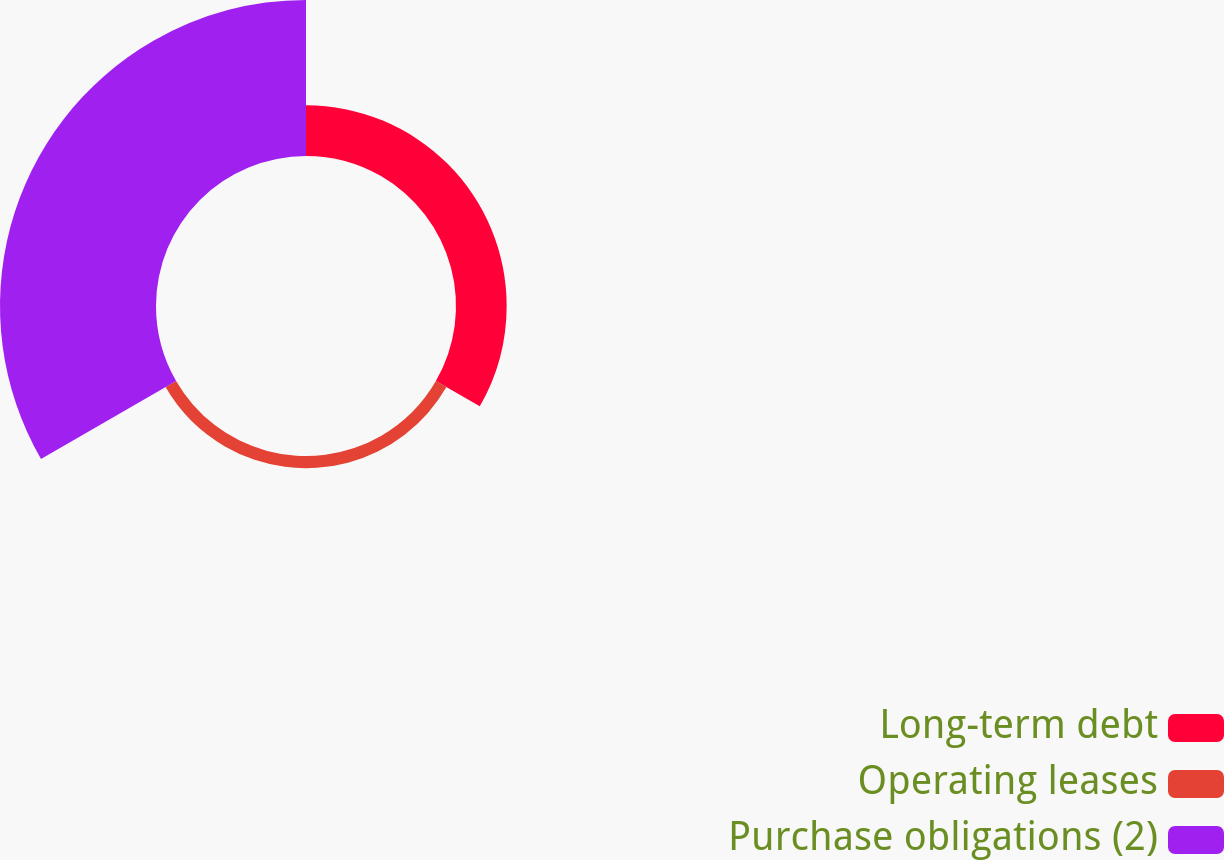Convert chart to OTSL. <chart><loc_0><loc_0><loc_500><loc_500><pie_chart><fcel>Long-term debt<fcel>Operating leases<fcel>Purchase obligations (2)<nl><fcel>23.15%<fcel>5.56%<fcel>71.29%<nl></chart> 